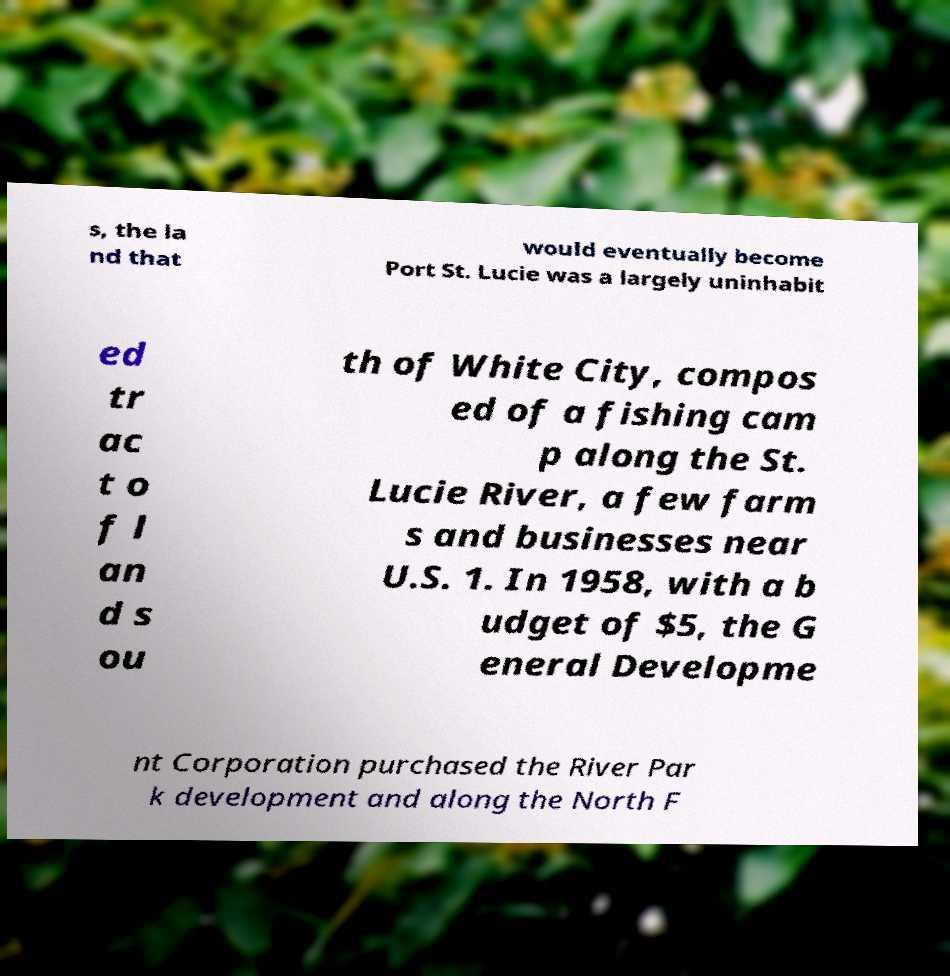Could you assist in decoding the text presented in this image and type it out clearly? s, the la nd that would eventually become Port St. Lucie was a largely uninhabit ed tr ac t o f l an d s ou th of White City, compos ed of a fishing cam p along the St. Lucie River, a few farm s and businesses near U.S. 1. In 1958, with a b udget of $5, the G eneral Developme nt Corporation purchased the River Par k development and along the North F 